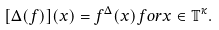Convert formula to latex. <formula><loc_0><loc_0><loc_500><loc_500>[ \Delta ( f ) ] ( x ) = f ^ { \Delta } ( x ) f o r x \in { \mathbb { T } } ^ { \kappa } .</formula> 